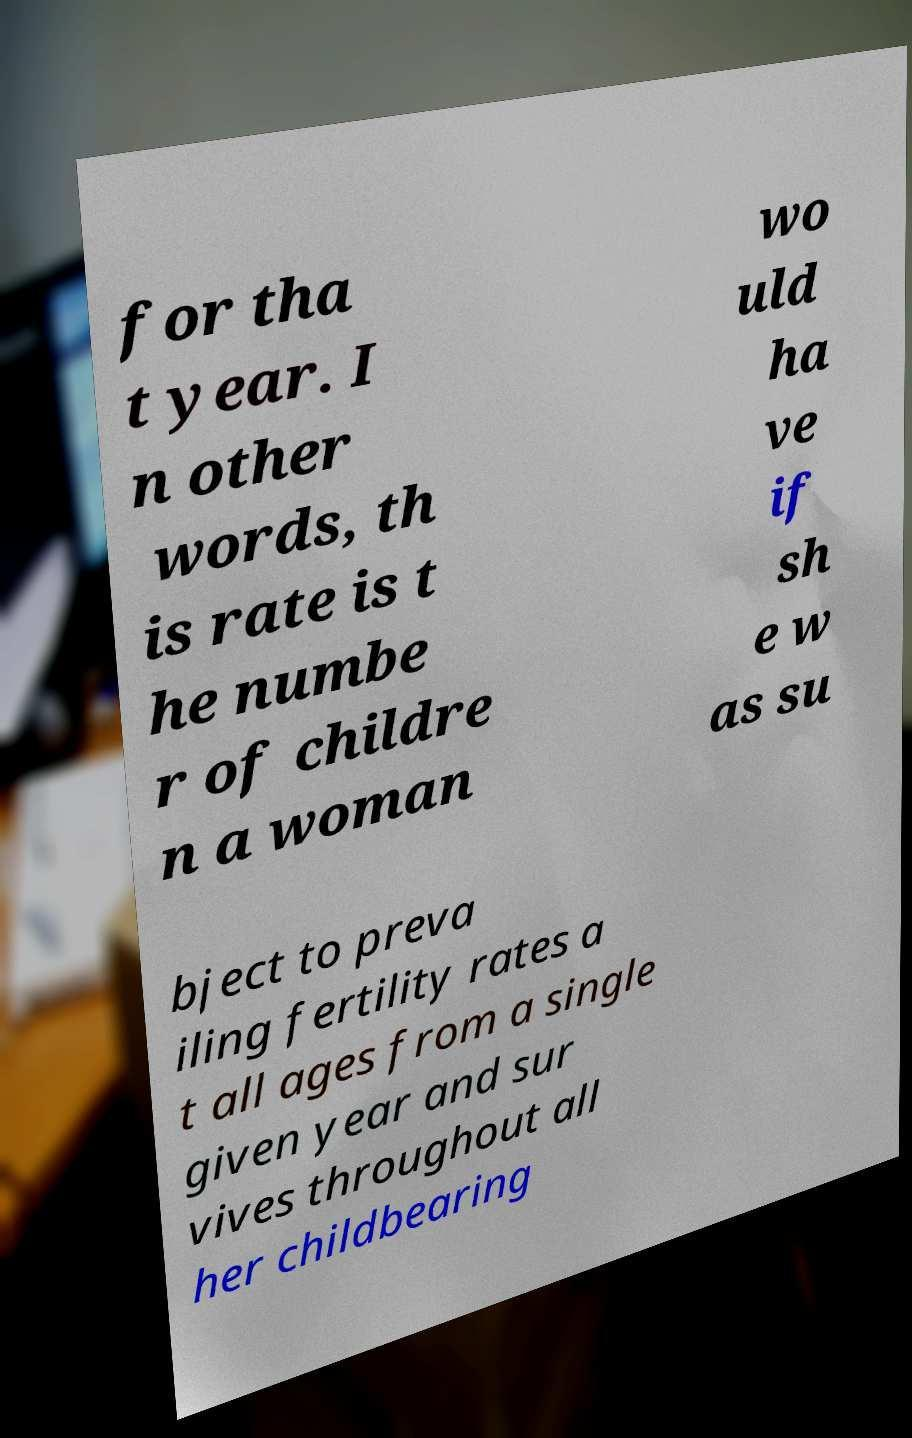What messages or text are displayed in this image? I need them in a readable, typed format. for tha t year. I n other words, th is rate is t he numbe r of childre n a woman wo uld ha ve if sh e w as su bject to preva iling fertility rates a t all ages from a single given year and sur vives throughout all her childbearing 